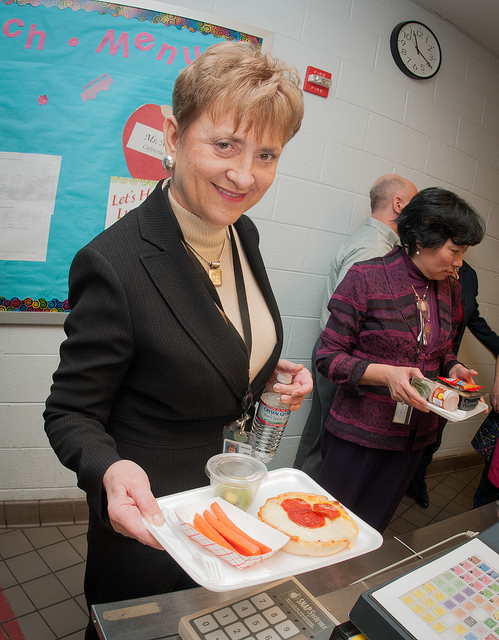What food is on the table? The table features a wholesome school lunch that includes a slice of pizza topped with tomato sauce and cheese, fresh carrot sticks, and a clear container of what appears to be fruit pieces. 